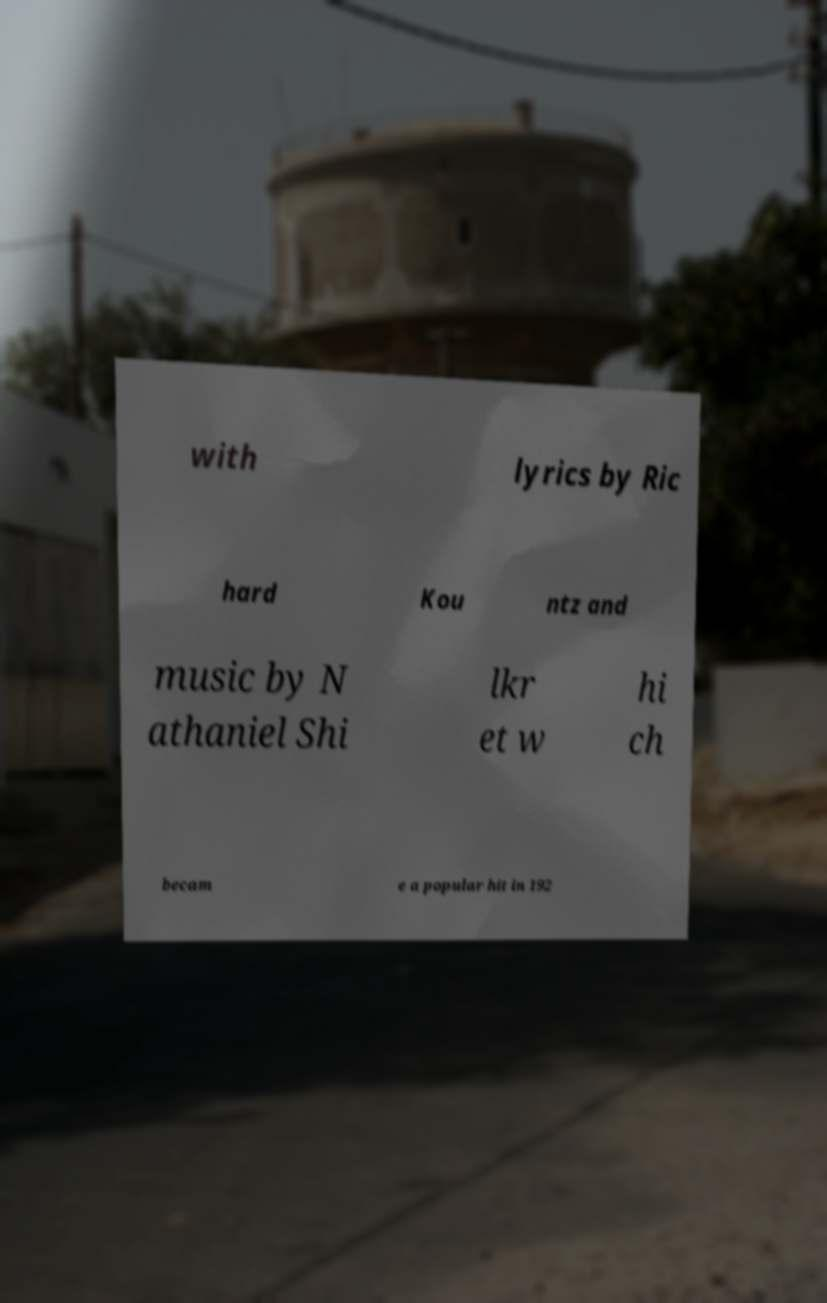Could you assist in decoding the text presented in this image and type it out clearly? with lyrics by Ric hard Kou ntz and music by N athaniel Shi lkr et w hi ch becam e a popular hit in 192 